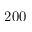<formula> <loc_0><loc_0><loc_500><loc_500>2 0 0</formula> 